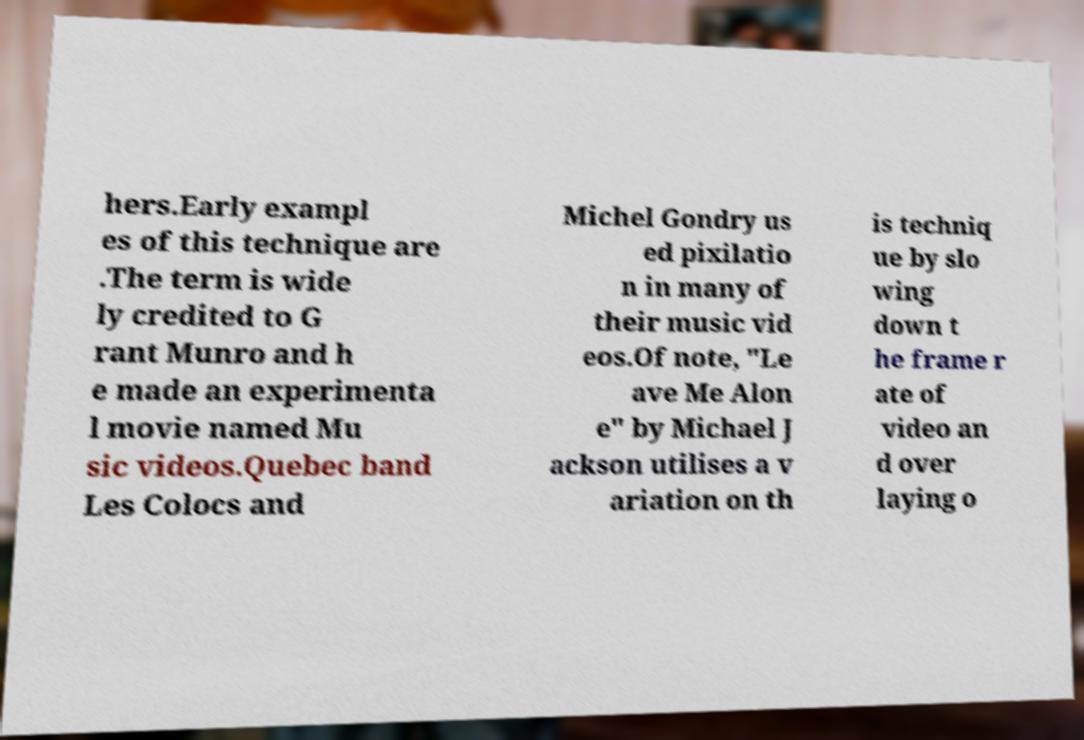What messages or text are displayed in this image? I need them in a readable, typed format. hers.Early exampl es of this technique are .The term is wide ly credited to G rant Munro and h e made an experimenta l movie named Mu sic videos.Quebec band Les Colocs and Michel Gondry us ed pixilatio n in many of their music vid eos.Of note, "Le ave Me Alon e" by Michael J ackson utilises a v ariation on th is techniq ue by slo wing down t he frame r ate of video an d over laying o 